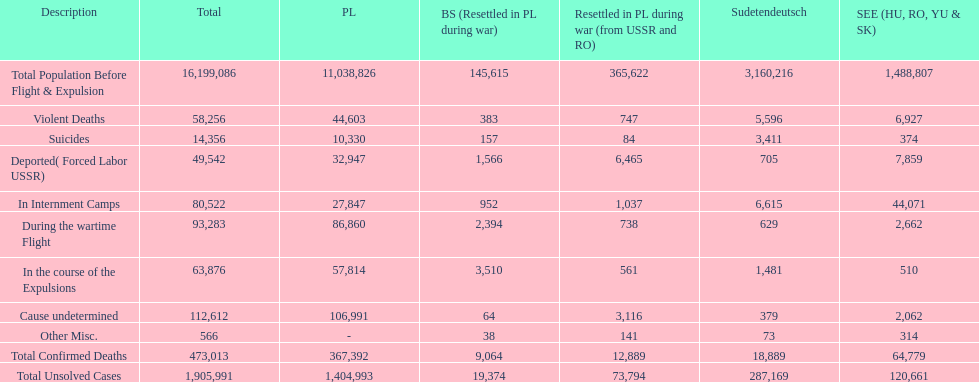What is the overall count of violent fatalities in all areas? 58,256. Help me parse the entirety of this table. {'header': ['Description', 'Total', 'PL', 'BS (Resettled in PL during war)', 'Resettled in PL during war (from USSR and RO)', 'Sudetendeutsch', 'SEE (HU, RO, YU & SK)'], 'rows': [['Total Population Before Flight & Expulsion', '16,199,086', '11,038,826', '145,615', '365,622', '3,160,216', '1,488,807'], ['Violent Deaths', '58,256', '44,603', '383', '747', '5,596', '6,927'], ['Suicides', '14,356', '10,330', '157', '84', '3,411', '374'], ['Deported( Forced Labor USSR)', '49,542', '32,947', '1,566', '6,465', '705', '7,859'], ['In Internment Camps', '80,522', '27,847', '952', '1,037', '6,615', '44,071'], ['During the wartime Flight', '93,283', '86,860', '2,394', '738', '629', '2,662'], ['In the course of the Expulsions', '63,876', '57,814', '3,510', '561', '1,481', '510'], ['Cause undetermined', '112,612', '106,991', '64', '3,116', '379', '2,062'], ['Other Misc.', '566', '-', '38', '141', '73', '314'], ['Total Confirmed Deaths', '473,013', '367,392', '9,064', '12,889', '18,889', '64,779'], ['Total Unsolved Cases', '1,905,991', '1,404,993', '19,374', '73,794', '287,169', '120,661']]} 